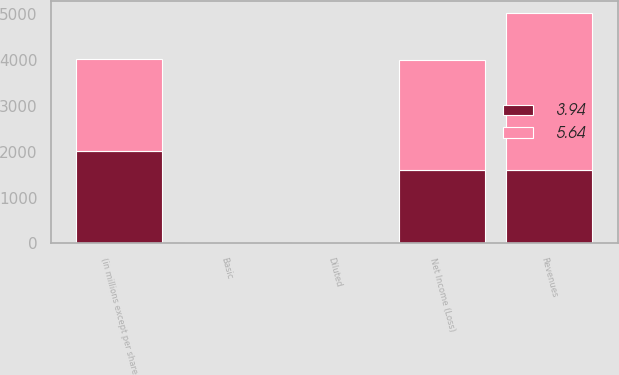Convert chart. <chart><loc_0><loc_0><loc_500><loc_500><stacked_bar_chart><ecel><fcel>(in millions except per share<fcel>Revenues<fcel>Net Income (Loss)<fcel>Basic<fcel>Diluted<nl><fcel>5.64<fcel>2015<fcel>3428<fcel>2393<fcel>5.64<fcel>5.64<nl><fcel>3.94<fcel>2014<fcel>1607<fcel>1607<fcel>4.01<fcel>3.94<nl></chart> 